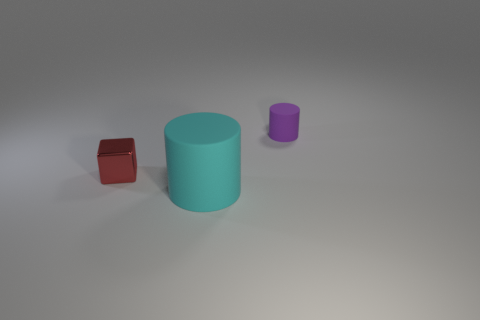Subtract all cylinders. How many objects are left? 1 Add 2 rubber objects. How many objects exist? 5 Subtract all rubber cylinders. Subtract all small cylinders. How many objects are left? 0 Add 2 big rubber cylinders. How many big rubber cylinders are left? 3 Add 3 big gray matte things. How many big gray matte things exist? 3 Subtract 1 red blocks. How many objects are left? 2 